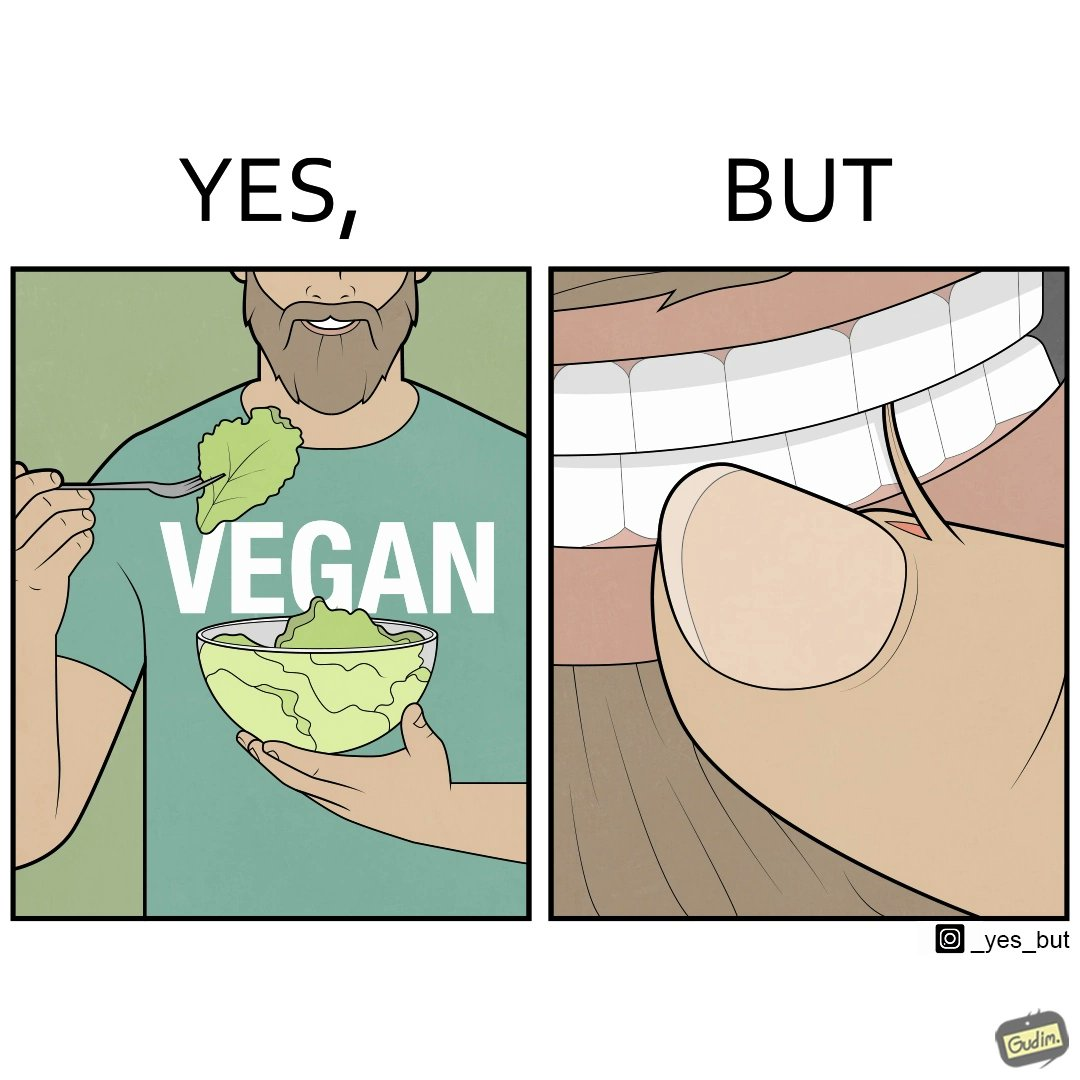What makes this image funny or satirical? The image is funny because while the man claims to be vegan, he is biting skin off his own hand. 